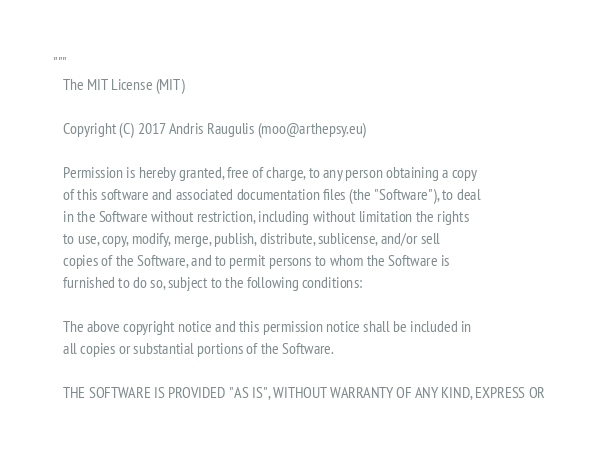<code> <loc_0><loc_0><loc_500><loc_500><_Python_>"""
   The MIT License (MIT)

   Copyright (C) 2017 Andris Raugulis (moo@arthepsy.eu)

   Permission is hereby granted, free of charge, to any person obtaining a copy
   of this software and associated documentation files (the "Software"), to deal
   in the Software without restriction, including without limitation the rights
   to use, copy, modify, merge, publish, distribute, sublicense, and/or sell
   copies of the Software, and to permit persons to whom the Software is
   furnished to do so, subject to the following conditions:

   The above copyright notice and this permission notice shall be included in
   all copies or substantial portions of the Software.

   THE SOFTWARE IS PROVIDED "AS IS", WITHOUT WARRANTY OF ANY KIND, EXPRESS OR</code> 